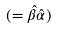<formula> <loc_0><loc_0><loc_500><loc_500>( = \hat { \beta } \hat { \alpha } )</formula> 